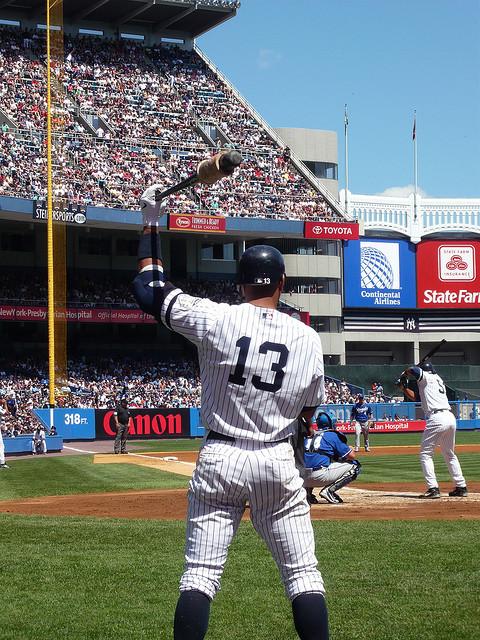What game is happening here?
Quick response, please. Baseball. What insurance company logo do you see?
Short answer required. State farm. Do you think the number 13 is unlucky?
Answer briefly. No. 